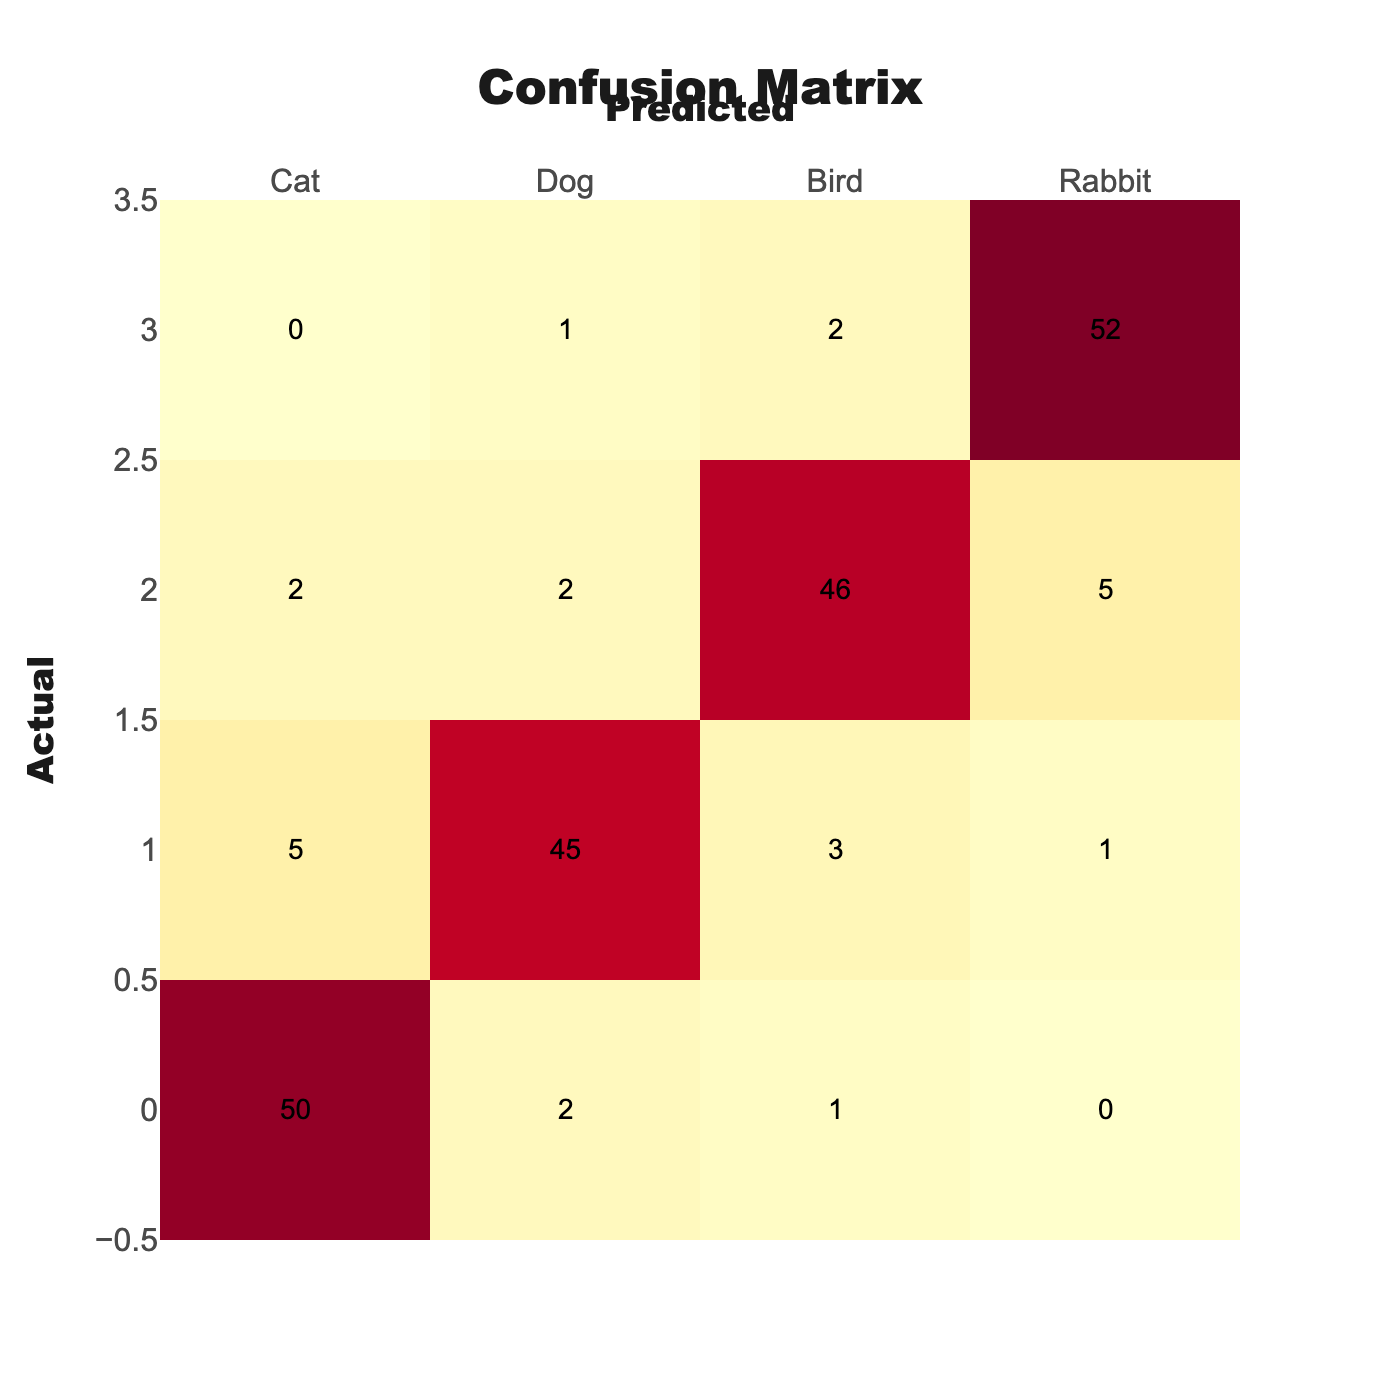What is the number of correct predictions for the Cat category? The correct predictions for the Cat category can be found in the cell where the Actual and Predicted categories meet for the Cat. The table shows 50 for Cat, meaning that 50 instances of Cat were correctly predicted.
Answer: 50 How many times was a Dog incorrectly predicted as a Cat? To find how many times a Dog was incorrectly predicted as a Cat, we look at the cell in the Dog row and Cat column. The value is 5, indicating that there were 5 instances where the Dog was wrongly classified as Cat.
Answer: 5 What is the total number of predictions made for the Rabbit category? To find the total predictions for the Rabbit category, we sum all the values in the Rabbit row: (0 + 1 + 2 + 52) = 55. This means the system made 55 predictions for Rabbit.
Answer: 55 Is there a higher rate of false negatives for Dogs than for Birds? A false negative for Dogs is represented by instances where actual Dogs were predicted as something other than Dogs. This is calculated by summing the incorrect predictions for Dogs: (5 + 3 + 1) = 9. For Birds, false negatives are (2 + 2 + 5) = 9. Since both are equal, the answer is no, they are the same.
Answer: No What is the overall accuracy rate of the classification model? To calculate the overall accuracy, we need to sum the correct predictions: (50 + 45 + 46 + 52) = 193. Then sum all predictions: (50 + 2 + 1 + 0 + 5 + 45 + 3 + 1 + 2 + 2 + 46 + 5 + 0 + 1 + 2 + 52) = 168. Finally, the accuracy is calculated as correct predictions divided by total predictions: 193/168, which equals approximately 0.57 or 57%.
Answer: 57% How many total instances were misclassified across all categories? To find the total misclassifications, we calculate the sum of all incorrect predictions for each category. For Cat: (2 + 1 + 0) = 3, for Dog: (5 + 3 + 1) = 9, for Bird: (2 + 2 + 5) = 9, and for Rabbit: (0 + 1 + 2) = 3. The total misclassifications are 3 + 9 + 9 + 3 = 24.
Answer: 24 